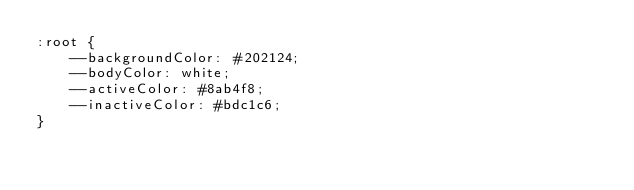Convert code to text. <code><loc_0><loc_0><loc_500><loc_500><_CSS_>:root {
    --backgroundColor: #202124;
    --bodyColor: white;
    --activeColor: #8ab4f8;
    --inactiveColor: #bdc1c6;
}
</code> 